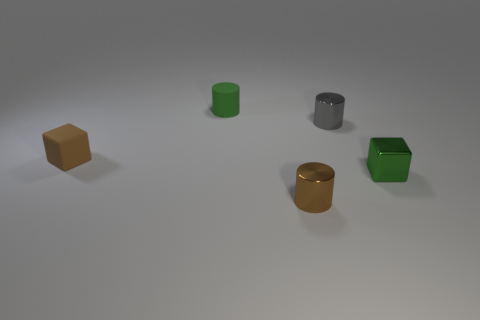Subtract all metal cylinders. How many cylinders are left? 1 Add 1 small green matte objects. How many objects exist? 6 Subtract all cylinders. How many objects are left? 2 Add 2 small brown cylinders. How many small brown cylinders exist? 3 Subtract 0 purple spheres. How many objects are left? 5 Subtract all small objects. Subtract all tiny red shiny cylinders. How many objects are left? 0 Add 3 small metallic things. How many small metallic things are left? 6 